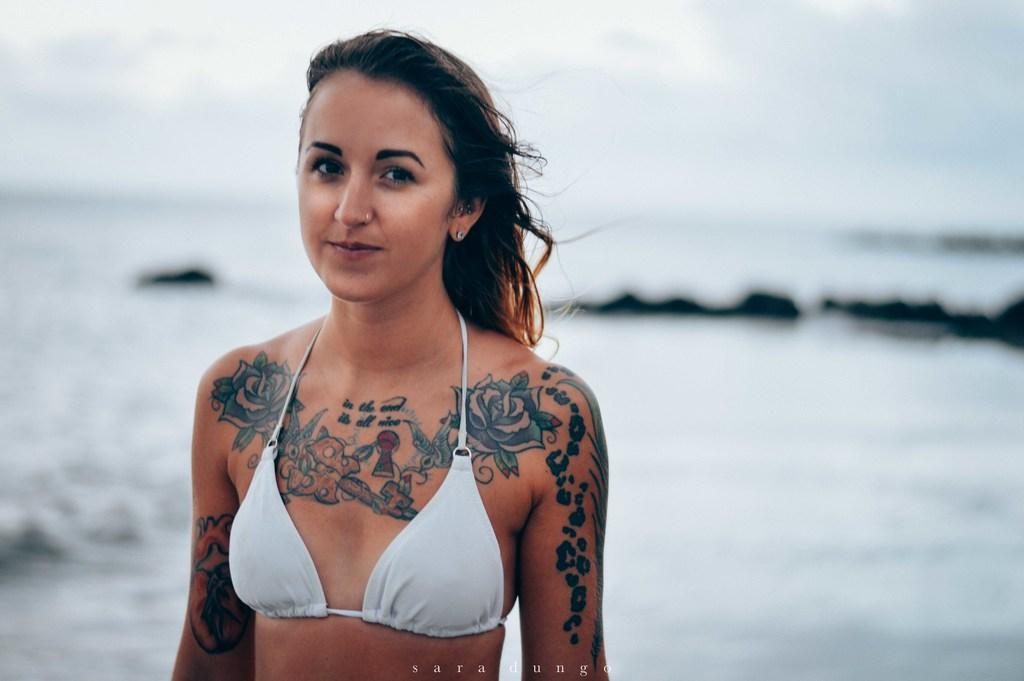What is the main subject of the image? There is a lady standing in the image. What can be seen in the background of the image? There is a sea and sky visible in the background of the image. Can you see a cat kissing the lady's brain in the image? There is no cat or brain visible in the image, and therefore no such activity can be observed. 